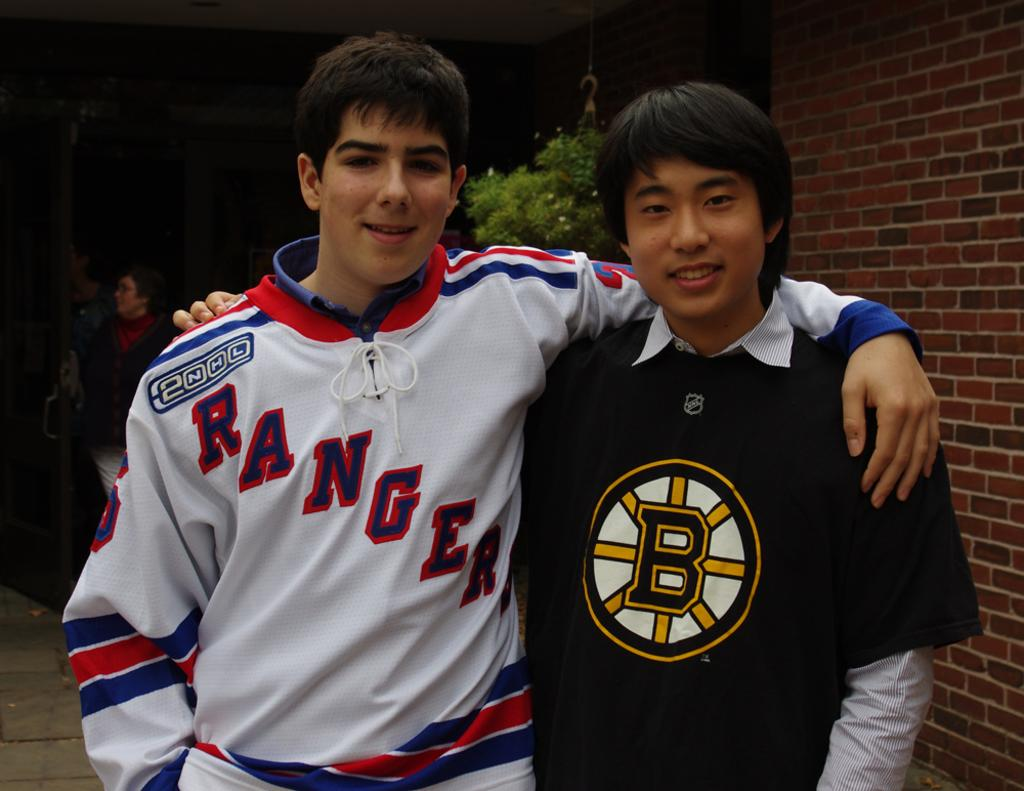<image>
Give a short and clear explanation of the subsequent image. Two young men smile for the picture and one of them has a jersey that reads "Rangers". 